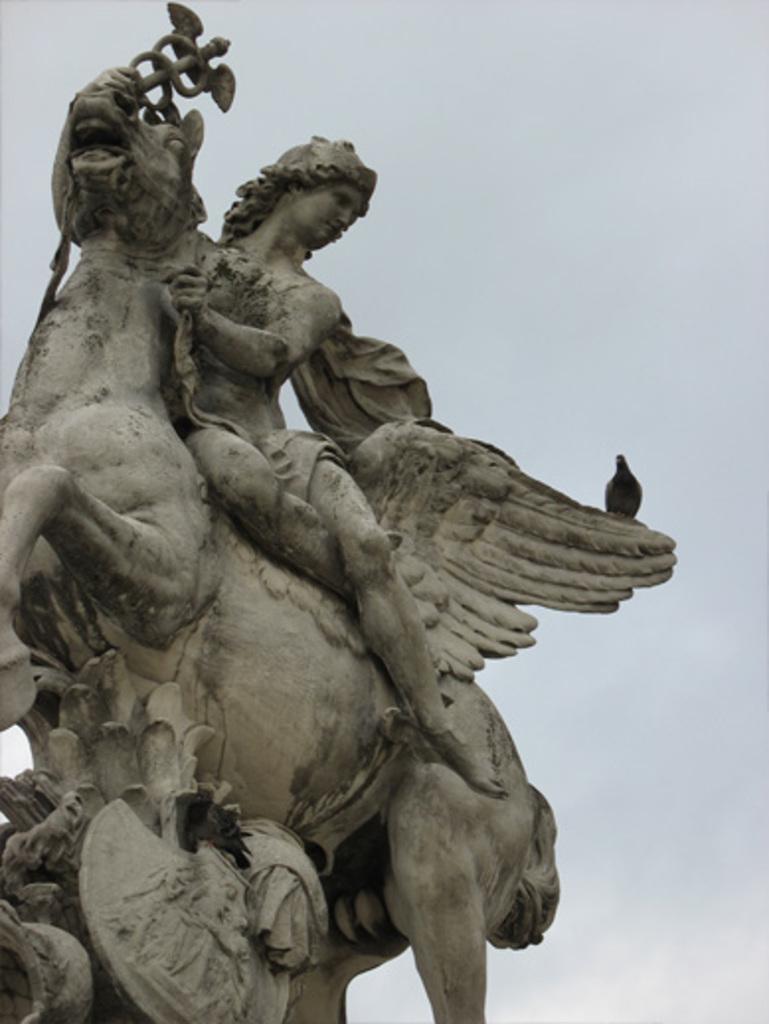Describe this image in one or two sentences. In this picture I can see birds on the statue, and in the background there is the sky. 